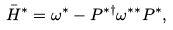Convert formula to latex. <formula><loc_0><loc_0><loc_500><loc_500>\bar { H } ^ { * } = \omega ^ { * } - P ^ { * \dagger } \omega ^ { * * } P ^ { * } ,</formula> 